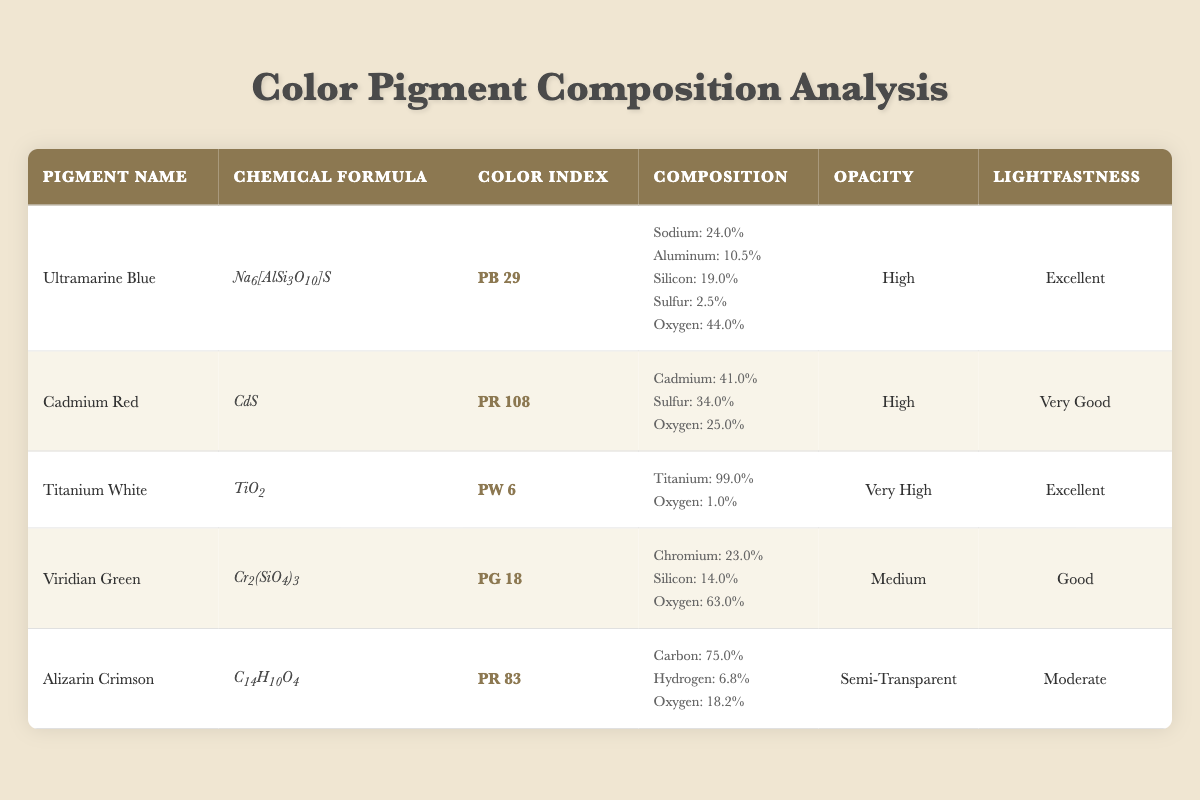What is the chemical formula for Titanium White? Referring to the "Chemical Formula" column in the row corresponding to "Titanium White," it is provided as TiO2.
Answer: TiO2 Which pigment has the highest opacity? By examining the "Opacity" column, Titanium White is noted to have "Very High" opacity, which is the highest rating listed.
Answer: Titanium White What is the lightfastness rating of Cadmium Red? The "Lightfastness" column specifies that for Cadmium Red, the rating is "Very Good."
Answer: Very Good What is the percentage composition of Oxygen in Ultramarine Blue? The "Composition" section for Ultramarine Blue lists Oxygen at 44.0%.
Answer: 44.0% Which pigments contain sulfur? From the "Composition" columns, both Cadmium Red (34.0% Sulfur) and Ultramarine Blue (2.5% Sulfur) contain sulfur.
Answer: Cadmium Red and Ultramarine Blue What is the sum of the percentages of all components present in Alizarin Crimson? The composition of Alizarin Crimson is given as Carbon: 75.0%, Hydrogen: 6.8%, Oxygen: 18.2%. Adding these together gives 75.0 + 6.8 + 18.2 = 100.0%.
Answer: 100.0% Does any pigment have "Good" lightfastness? Checking the "Lightfastness" column, Viridian Green has a rating classified as "Good."
Answer: Yes Which pigment has the lowest percentage of Oxygen composition? Reviewing the "Composition" values, Titanium White has an Oxygen percentage of 1.0%, which is the lowest compared to others.
Answer: Titanium White Calculate the average opacity from the pigments listed. The opacity ratings present are: High (2), Very High (1), Medium (1), and Semi-Transparent (1) can be categorized, but a strict average isn't numerical. One could conceptualize an average based on opacity effectiveness, influenced predominantly by high ratings such as Titanium White. Thus, it skews toward higher values.
Answer: Average is skewed towards high Which pigment has the highest concentration of a single element? In Titanium White, Titanium constitutes 99.0% of its composition, which is indeed the highest concentration compared to all other pigments' compositions.
Answer: Titanium White 